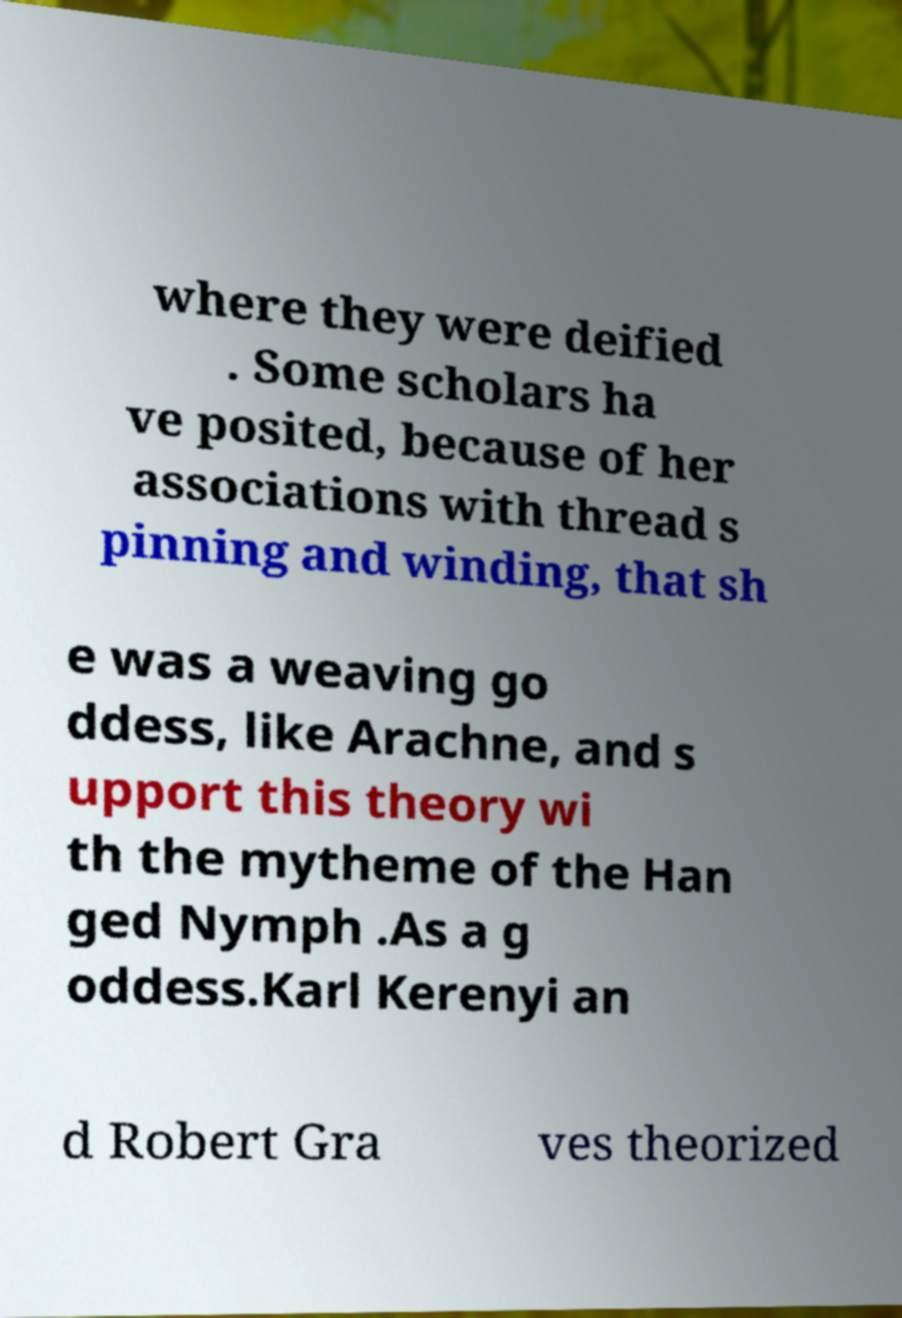Could you assist in decoding the text presented in this image and type it out clearly? where they were deified . Some scholars ha ve posited, because of her associations with thread s pinning and winding, that sh e was a weaving go ddess, like Arachne, and s upport this theory wi th the mytheme of the Han ged Nymph .As a g oddess.Karl Kerenyi an d Robert Gra ves theorized 